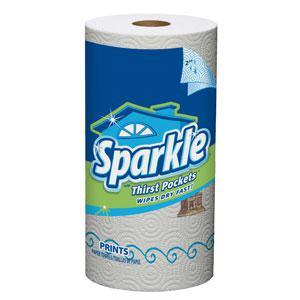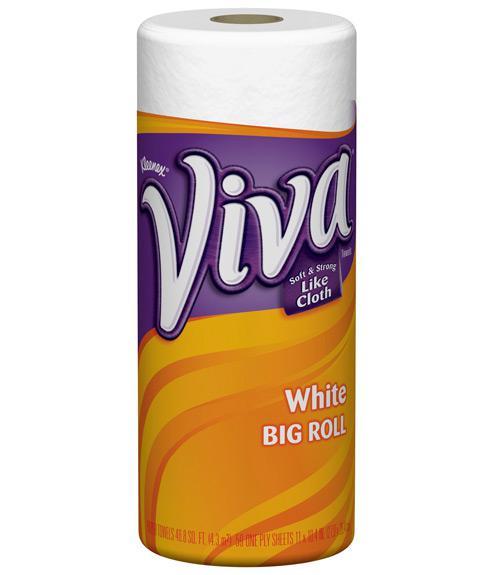The first image is the image on the left, the second image is the image on the right. Assess this claim about the two images: "Each image shows a single upright roll of paper towels, and the left and right rolls do not have identical packaging.". Correct or not? Answer yes or no. Yes. The first image is the image on the left, the second image is the image on the right. Evaluate the accuracy of this statement regarding the images: "There are exactly two rolls of paper towels.". Is it true? Answer yes or no. Yes. 